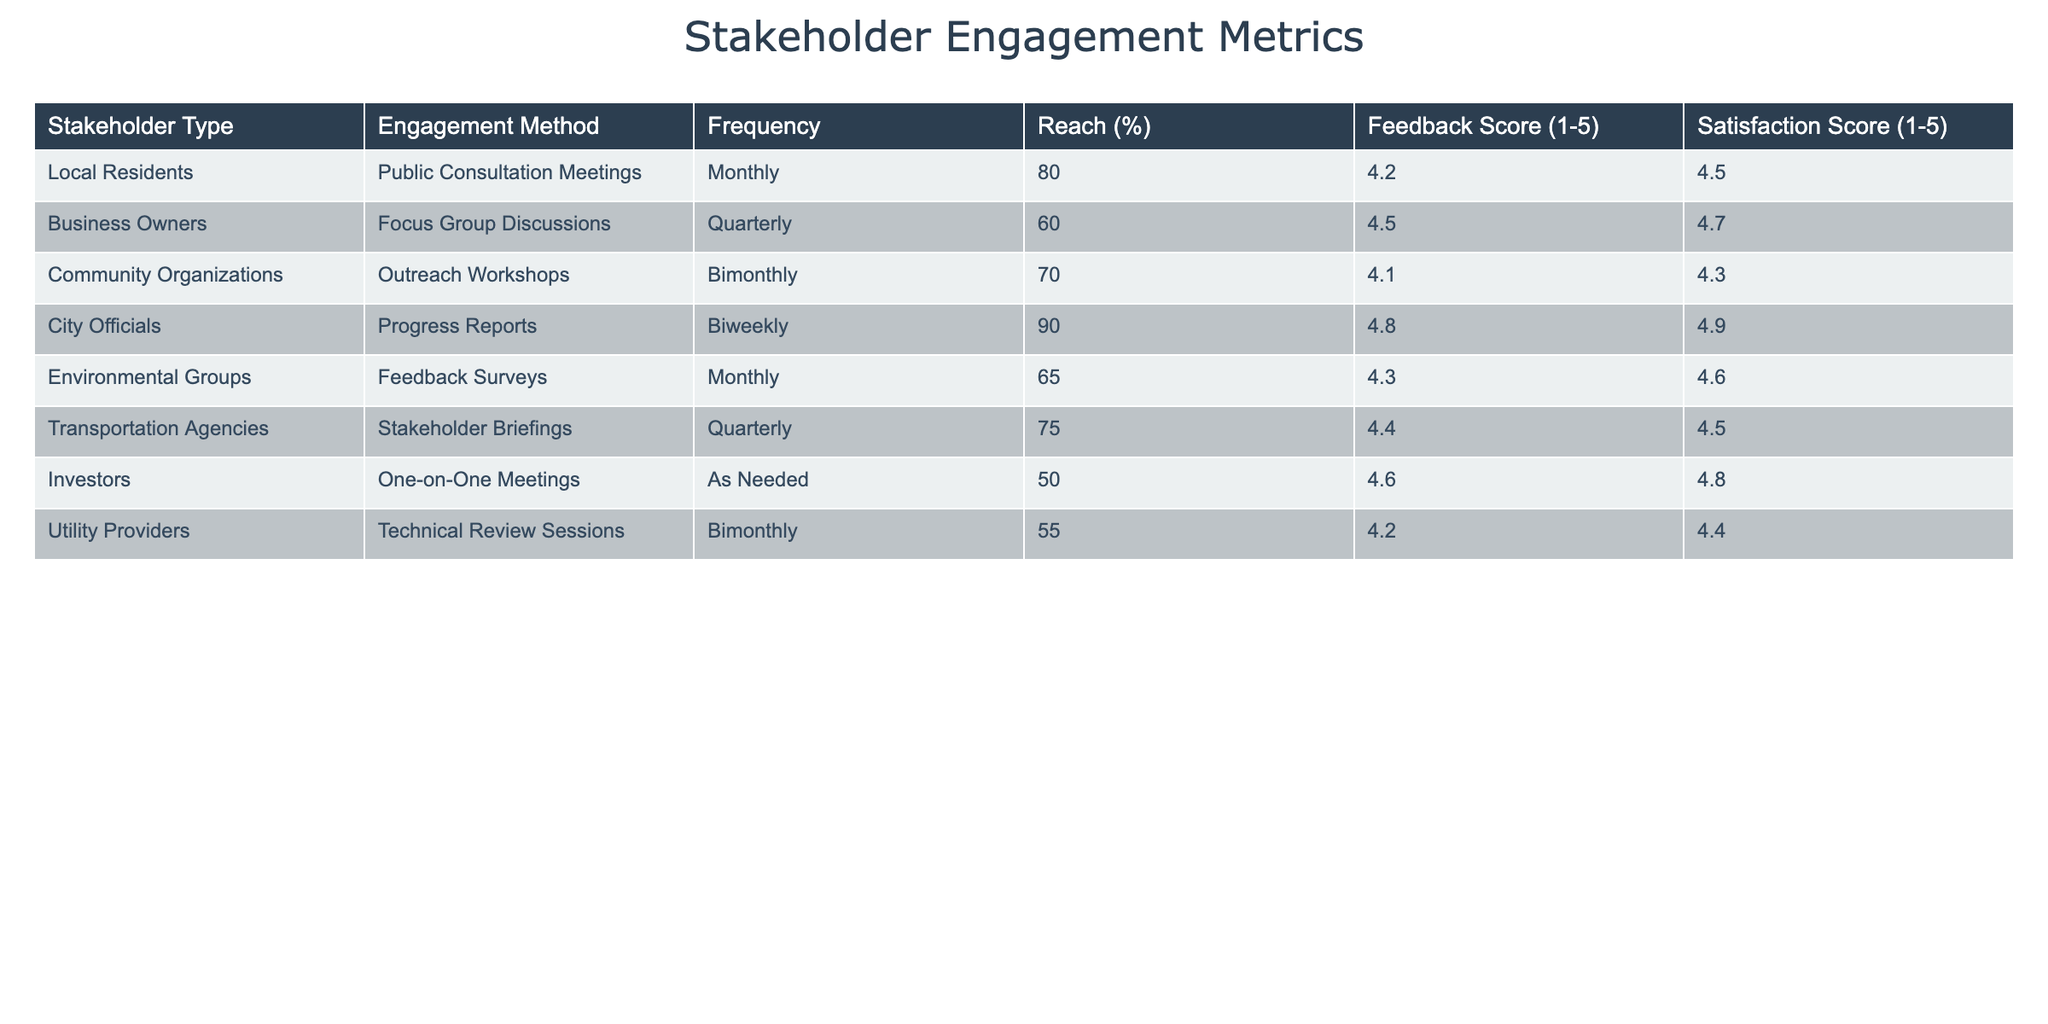What is the reach percentage of local residents in the engagement process? The reach percentage for local residents is directly taken from the table under the "Reach (%)" column, corresponding to the "Local Residents" row. It shows 80% as the reach percentage.
Answer: 80% Which stakeholder type has the highest feedback score? The feedback scores can be compared across all rows in the table. The "City Officials" have the highest feedback score listed as 4.8.
Answer: City Officials What is the average satisfaction score for stakeholder engagement methods that occur quarterly? To find the average satisfaction score for quarterly methods, we extract the satisfaction scores for "Business Owners" and "Transportation Agencies," which are 4.7 and 4.5, respectively. The sum is 4.7 + 4.5 = 9.2, and with 2 data points, the average is 9.2 / 2 = 4.6.
Answer: 4.6 Is the feedback score for environmental groups greater than 4? Looking at the feedback score for "Environmental Groups" in the table, it shows a score of 4.3. Since 4.3 is greater than 4, the statement is true.
Answer: Yes Which engagement method has the lowest reach percentage, and what is that percentage? To determine the lowest reach percentage, we review the "Reach (%)" column across all rows. The "Investors" have the lowest reach percentage at 50%.
Answer: Investors, 50% What is the difference between the highest and lowest satisfaction scores among the stakeholder types? We first identify the highest satisfaction score, which is 4.9 from "City Officials." The lowest is 4.3 from "Community Organizations." The difference is 4.9 - 4.3 = 0.6.
Answer: 0.6 Are public consultation meetings held more frequently than technical review sessions? The frequency for public consultation meetings is "Monthly," while for technical review sessions, it is "Bimonthly." Since "Monthly" indicates more frequent occurrence than "Bimonthly," the statement is true.
Answer: Yes How many engagement methods occur bimonthly, and what are they? We look at the frequency column and identify the rows with "Bimonthly." There are two: "Community Organizations" (Outreach Workshops) and "Utility Providers" (Technical Review Sessions).
Answer: 2 methods: Outreach Workshops, Technical Review Sessions What is the average reach percentage for all stakeholders involved? We sum up all the reach percentages: 80 + 60 + 70 + 90 + 65 + 75 + 50 + 55 = 600. There are 8 stakeholders, so the average is 600 / 8 = 75.
Answer: 75 